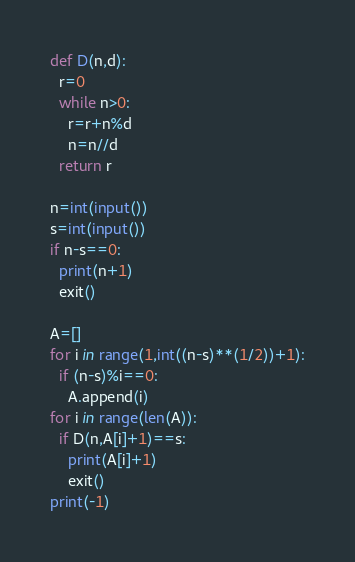Convert code to text. <code><loc_0><loc_0><loc_500><loc_500><_Python_>def D(n,d):
  r=0
  while n>0:
    r=r+n%d
    n=n//d
  return r

n=int(input())
s=int(input())
if n-s==0:
  print(n+1)
  exit()

A=[]
for i in range(1,int((n-s)**(1/2))+1):
  if (n-s)%i==0:
    A.append(i)
for i in range(len(A)):
  if D(n,A[i]+1)==s:
    print(A[i]+1)
    exit()
print(-1)</code> 